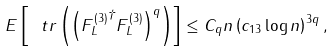<formula> <loc_0><loc_0><loc_500><loc_500>E \left [ \ t r \left ( \left ( { { F } _ { L } ^ { ( 3 ) } } ^ { \dagger } { { F } _ { L } ^ { ( 3 ) } } \right ) ^ { q } \right ) \right ] \leq C _ { q } n \left ( c _ { 1 3 } \log n \right ) ^ { 3 q } ,</formula> 